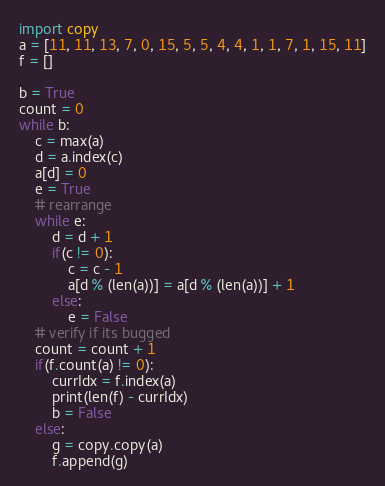Convert code to text. <code><loc_0><loc_0><loc_500><loc_500><_Python_>import copy
a = [11, 11, 13, 7, 0, 15, 5, 5, 4, 4, 1, 1, 7, 1, 15, 11]
f = []

b = True
count = 0
while b:
    c = max(a)
    d = a.index(c)
    a[d] = 0
    e = True
    # rearrange
    while e:
        d = d + 1
        if(c != 0):
            c = c - 1
            a[d % (len(a))] = a[d % (len(a))] + 1
        else:
            e = False
    # verify if its bugged
    count = count + 1
    if(f.count(a) != 0):
        currIdx = f.index(a)
        print(len(f) - currIdx)
        b = False
    else:
        g = copy.copy(a)
        f.append(g)</code> 